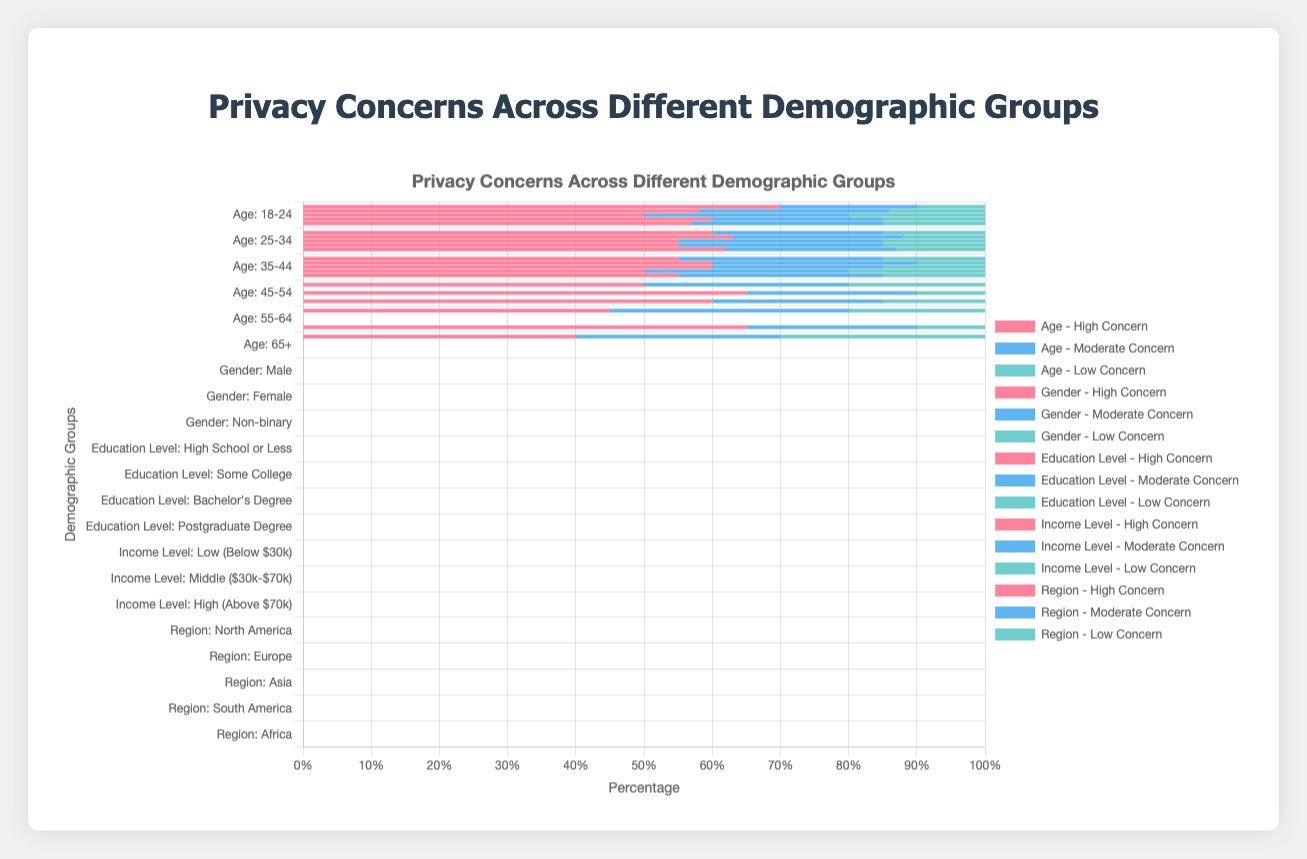Which age group reports the highest level of high concern about privacy? The age group 18-24 shows 70% of respondents reporting high concern, which is the highest level of high concern among all age groups.
Answer: 18-24 How do the privacy concerns of males compare to females in terms of high concern? Males have 58% reporting high concern, while females have 63% reporting high concern. Thus, females show a higher level of high concern about privacy than males.
Answer: Females What is the total moderate concern percentage for the age groups 55-64 and 65+? The moderate concern percentage for the 55-64 age group is 35%. For the 65+ age group, it is 30%. Adding them together gives 35% + 30% = 65%.
Answer: 65% Which demographic group shows the greatest difference between high concern and low concern within the group? The 18-24 age group shows the greatest difference between high concern (70%) and low concern (10%), with a difference of 60 percentage points.
Answer: 18-24 Which educational level exhibits the lowest level of low concern? The Postgraduate Degree educational level shows the lowest level of low concern at 10%.
Answer: Postgraduate Degree Compare the high concern levels between North America and Europe. North America has 57% reporting high concern, while Europe has 62% reporting high concern. Therefore, Europe has a higher level of high concern compared to North America.
Answer: Europe What is the average percentage of high concern for the Age demographic group? The high concern percentages for the Age groups are 70%, 60%, 55%, 50%, 45%, and 40%. Adding these gives 70 + 60 + 55 + 50 + 45 + 40 = 320. Dividing by the number of age groups (6) gives 320 / 6 = approximately 53.33%.
Answer: 53.33% What is the total percentage of respondents with low concern across all income levels? The low concern percentages for income levels are 15% for Low, 15% for Middle, and 20% for High. Adding them together gives 15 + 15 + 20 = 50%.
Answer: 50% Is the percentage of moderate concern higher in Non-binary individuals or in individuals with a Bachelor’s Degree? Non-binary individuals show 30% moderate concern, while individuals with a Bachelor’s Degree show 25% moderate concern. Therefore, moderate concern is higher in Non-binary individuals.
Answer: Non-binary How does the high concern level in South America compare to the high concern level in Africa? South America has 60% high concern, whereas Africa has 65% high concern. Thus, Africa has a higher level of high concern compared to South America.
Answer: Africa 